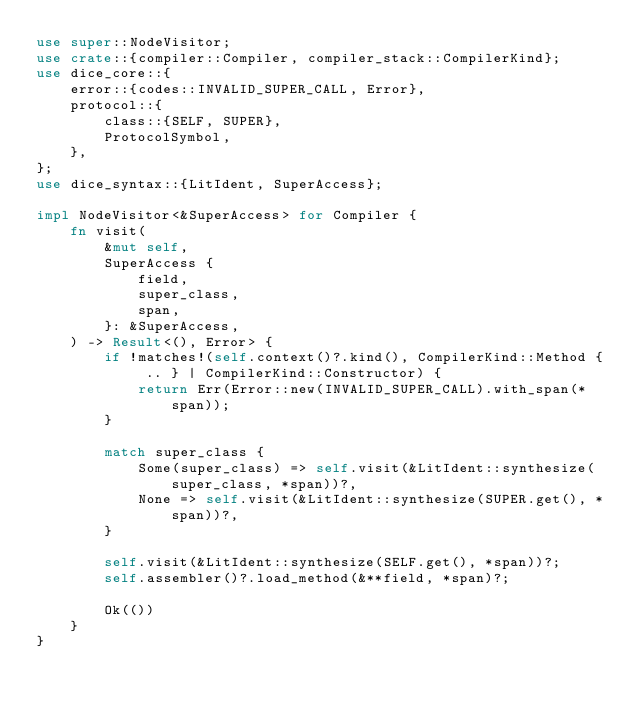Convert code to text. <code><loc_0><loc_0><loc_500><loc_500><_Rust_>use super::NodeVisitor;
use crate::{compiler::Compiler, compiler_stack::CompilerKind};
use dice_core::{
    error::{codes::INVALID_SUPER_CALL, Error},
    protocol::{
        class::{SELF, SUPER},
        ProtocolSymbol,
    },
};
use dice_syntax::{LitIdent, SuperAccess};

impl NodeVisitor<&SuperAccess> for Compiler {
    fn visit(
        &mut self,
        SuperAccess {
            field,
            super_class,
            span,
        }: &SuperAccess,
    ) -> Result<(), Error> {
        if !matches!(self.context()?.kind(), CompilerKind::Method { .. } | CompilerKind::Constructor) {
            return Err(Error::new(INVALID_SUPER_CALL).with_span(*span));
        }

        match super_class {
            Some(super_class) => self.visit(&LitIdent::synthesize(super_class, *span))?,
            None => self.visit(&LitIdent::synthesize(SUPER.get(), *span))?,
        }

        self.visit(&LitIdent::synthesize(SELF.get(), *span))?;
        self.assembler()?.load_method(&**field, *span)?;

        Ok(())
    }
}
</code> 